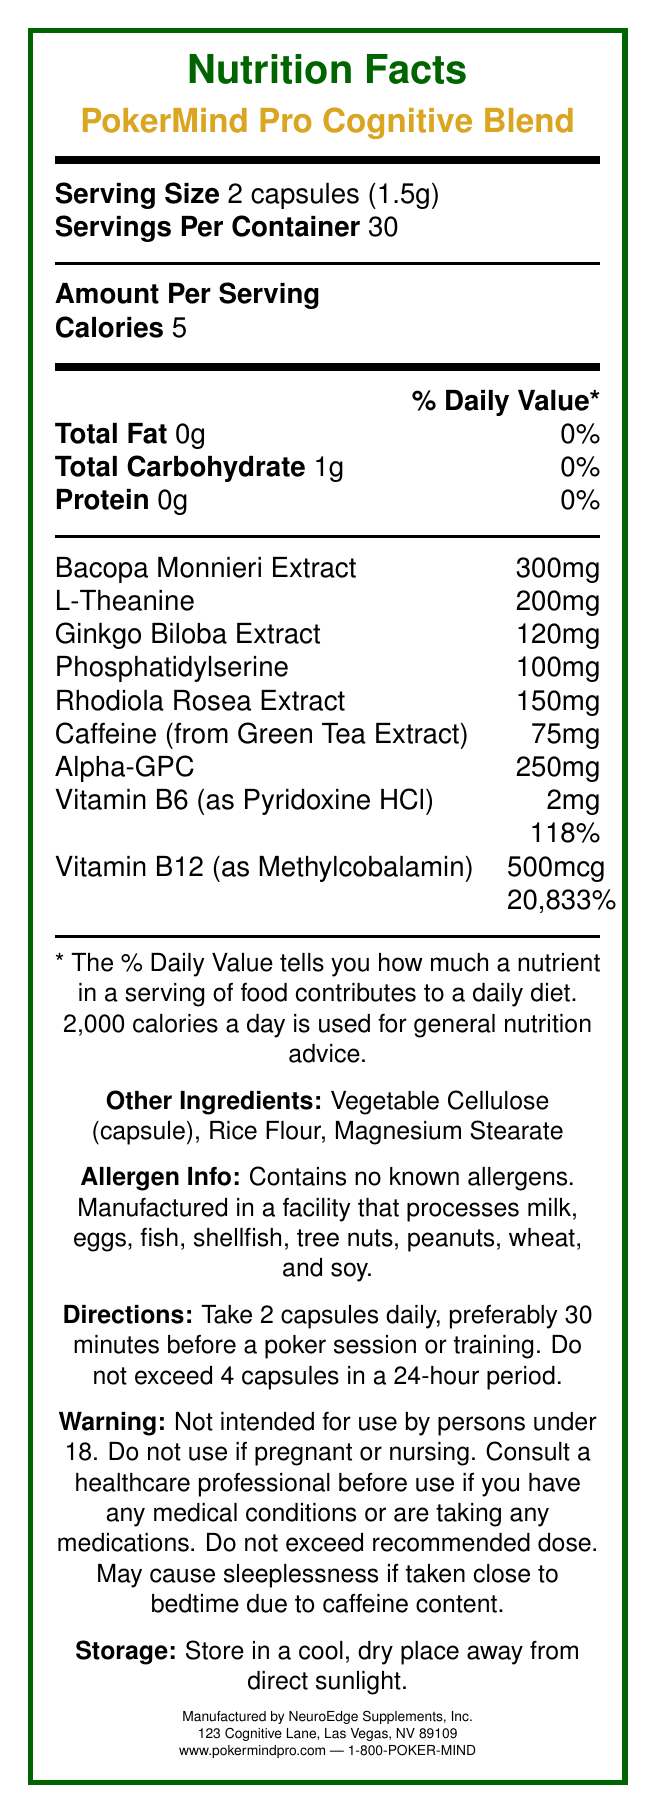What is the serving size of PokerMind Pro Cognitive Blend? The serving size is clearly indicated as 2 capsules (1.5g) under the "Serving Size" section.
Answer: 2 capsules (1.5g) How many servings are there per container? The document states the servings per container as 30.
Answer: 30 How many calories are in each serving? The amount per serving section lists that there are 5 calories per serving.
Answer: 5 What is the percentage of daily value for Vitamin B12 in one serving? The daily value percentage for Vitamin B12 is listed as 20,833%.
Answer: 20,833% Which ingredient has the highest daily value percentage? The daily value percentages are given for Vitamin B6 (118%) and Vitamin B12 (20,833%), so Vitamin B12 has the highest daily value percentage.
Answer: Vitamin B12 Does this supplement contain allergens? The allergen information states that it contains no known allergens.
Answer: No Who manufactures PokerMind Pro Cognitive Blend? The manufacturer information section lists NeuroEdge Supplements, Inc. as the manufacturer.
Answer: NeuroEdge Supplements, Inc. What is the recommended dosage for this supplement? The directions specify taking 2 capsules daily, preferably 30 minutes before a poker session or training.
Answer: 2 capsules daily, preferably 30 minutes before a poker session or training What is the main purpose of the supplement? A. Muscle building B. Cognitive performance in poker C. Weight loss D. Joint health The product name "PokerMind Pro Cognitive Blend" and its ingredients tailored for cognitive enhancement indicate its purpose is for cognitive performance in poker.
Answer: B. Cognitive performance in poker Which ingredient has the least amount per serving in milligrams? A. Bacopa Monnieri Extract B. L-Theanine C. Phosphatidylserine D. Caffeine Caffeine has the least amount per serving at 75mg among the listed options.
Answer: D. Caffeine Is this supplement suitable for someone under 18 years old? The warnings section states that the supplement is not intended for use by persons under 18.
Answer: No Summarize the main information provided in the document. This summary captures the key details about the product, including its purpose, nutritional content, ingredients, recommended dosage, and manufacturer information as per the document provided.
Answer: PokerMind Pro Cognitive Blend is a brain-boosting supplement aimed at enhancing cognitive performance in poker. Each serving consists of 2 capsules, with 30 servings per container, and provides 5 calories. The supplement contains various cognitive-enhancing ingredients such as Bacopa Monnieri Extract, L-Theanine, and Ginkgo Biloba Extract, along with significant amounts of Vitamin B6 and Vitamin B12. The directions recommend taking 2 capsules daily, preferably before a poker session. It is manufactured by NeuroEdge Supplements, Inc., and contains no known allergens. What is the total carbohydrate content per serving? The total carbohydrate content is listed as 1g per serving.
Answer: 1g Does the supplement contain any protein? The document states that there is 0g of protein per serving.
Answer: No What is the maximum dosage of capsules recommended within 24 hours? According to the directions, do not exceed 4 capsules in a 24-hour period.
Answer: 4 capsules Does the supplement contain Vitamin C? The document lists the ingredients and vitamins present but does not mention Vitamin C.
Answer: Not enough information What should you do if you are pregnant or nursing and want to take this supplement? The warning section advises consulting a healthcare professional before using if pregnant or nursing.
Answer: Consult a healthcare professional before use 